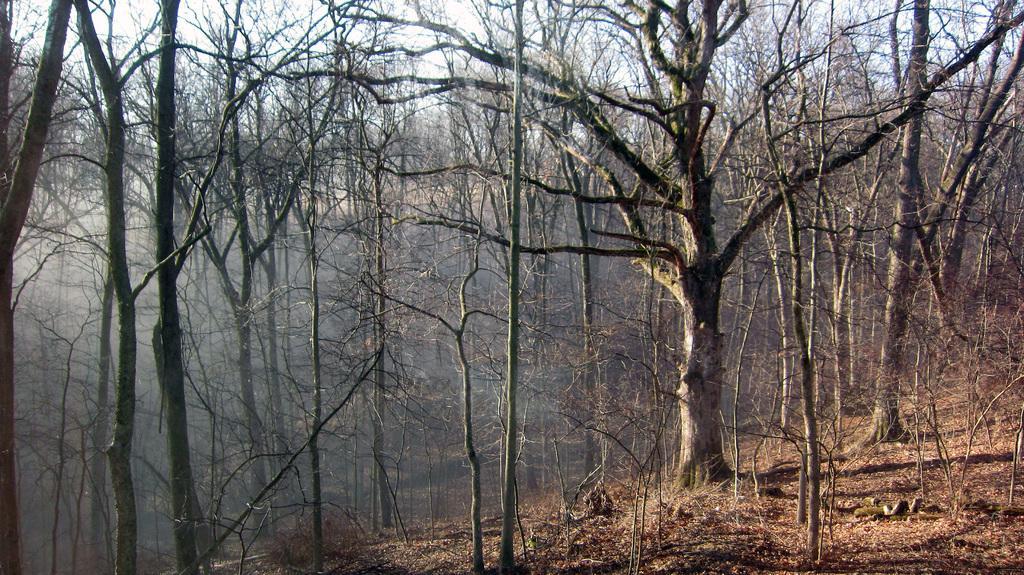Could you give a brief overview of what you see in this image? In this image we can see there are trees and plants. 